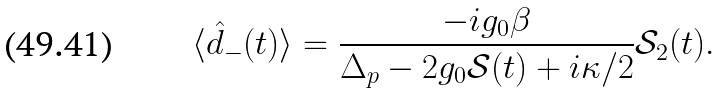Convert formula to latex. <formula><loc_0><loc_0><loc_500><loc_500>\langle \hat { d } _ { - } ( t ) \rangle = \frac { - i g _ { 0 } \beta } { \Delta _ { p } - 2 g _ { 0 } \mathcal { S } ( t ) + i \kappa / 2 } \mathcal { S } _ { 2 } ( t ) .</formula> 